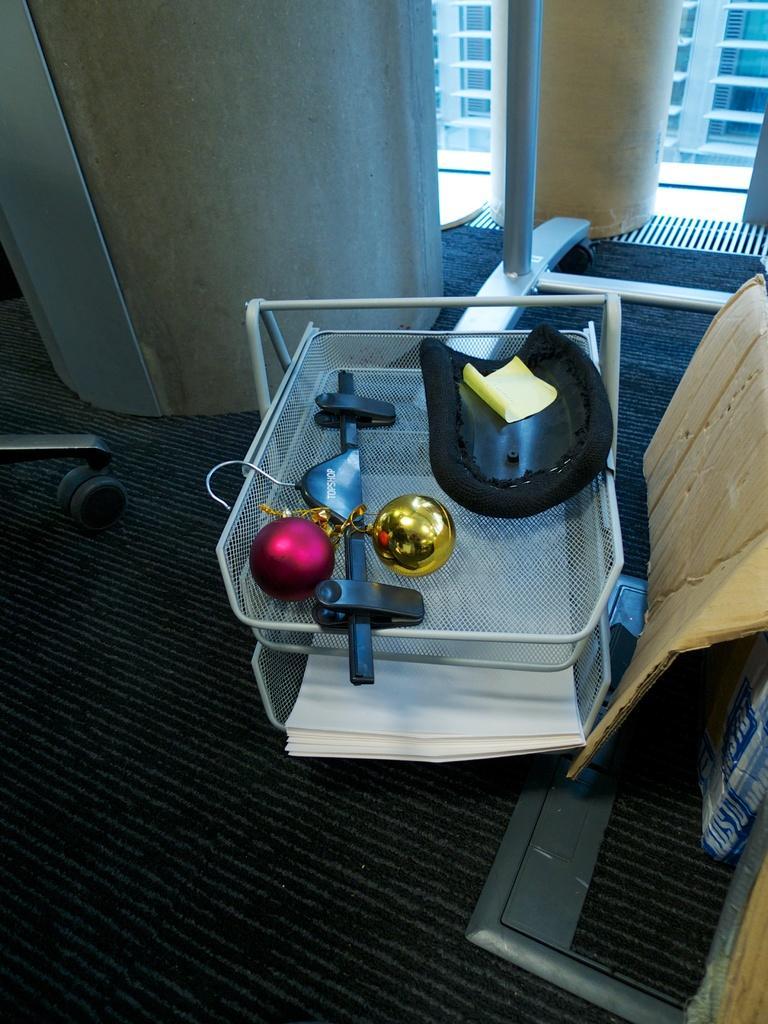Describe this image in one or two sentences. Here in this picture, in the front we can see some things present in a plastic stand, which is present on the floor and behind that we can see pillars present and beside that we can see a card board piece present and in the far we can see glass windows, through which we can see other buildings outside. 